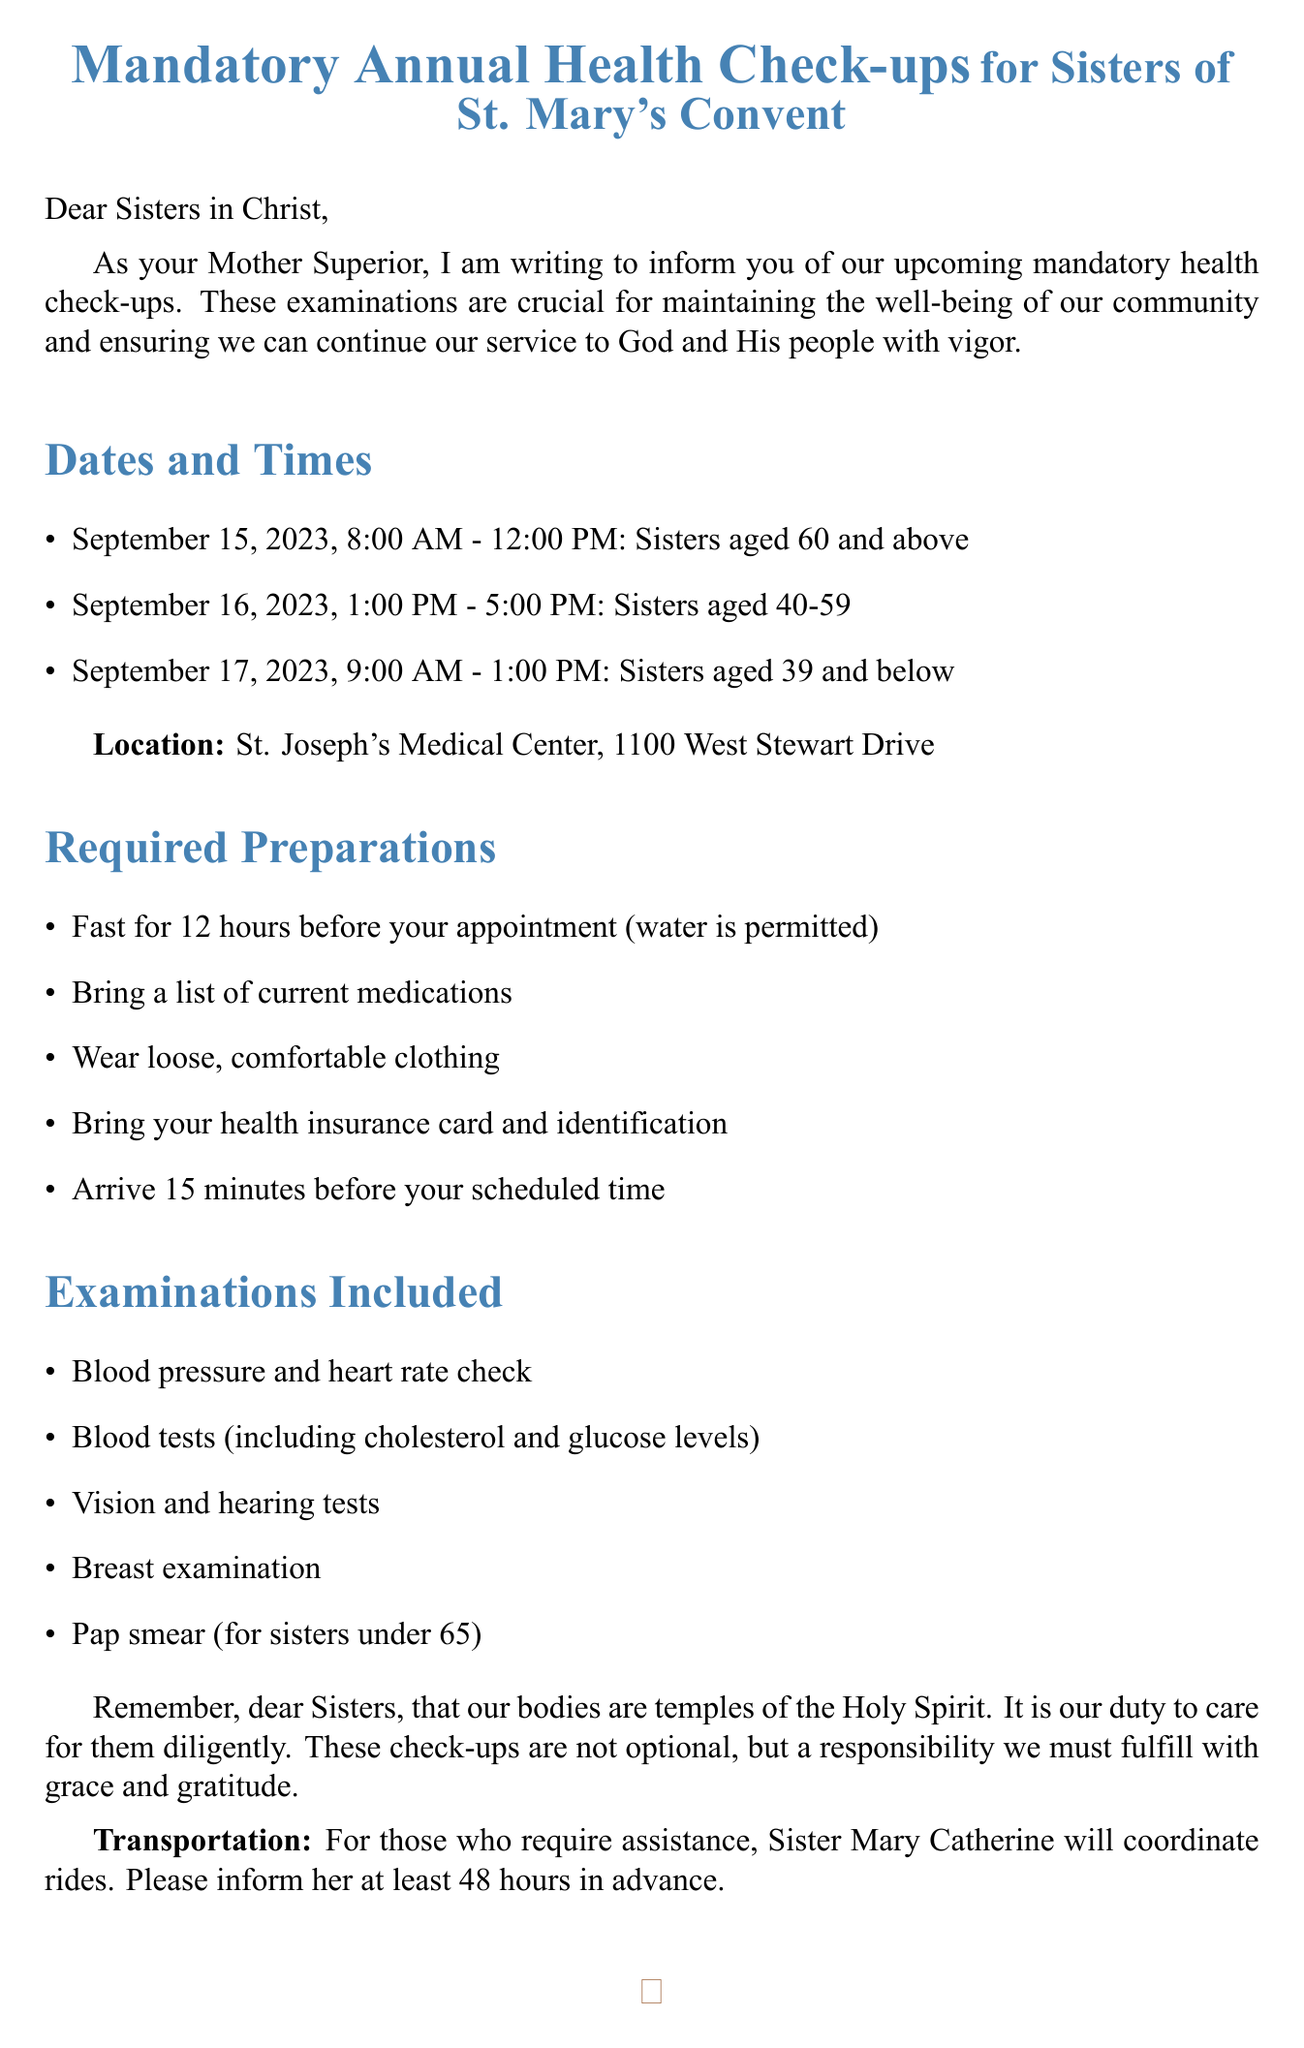What is the title of the memo? The title summarizes the purpose of the memo, which is about health check-ups for the sisters.
Answer: Mandatory Annual Health Check-ups for Sisters of St. Mary's Convent When is the health check-up for Sisters aged 40-59? This question pertains to the scheduling of health check-ups mentioned in the document.
Answer: September 16, 2023 What time should Sisters aged 39 and below arrive for their appointment? This reviews the preparation instructions related to timely arrival for health check-ups.
Answer: 15 minutes before their scheduled time Where will the health check-ups be held? This question seeks the location of the medical examinations specified in the memo.
Answer: St. Joseph's Medical Center, 1100 West Stewart Drive What is one of the required preparations for the health check-up? This examines the preparations required prior to the check-ups listed in the memo.
Answer: Fast for 12 hours before your appointment (water is permitted) How long after the check-ups will results be sent to the convent? The duration from the examinations to the receipt of results is a critical piece of information in the memo.
Answer: Two weeks Who will coordinate transportation for those in need? This question identifies the person responsible for arranging transportation as stated in the memo.
Answer: Sister Mary Catherine What is the religious context mentioned in the memo? This seeks to understand the principle guiding the health check-ups and caring for oneself as stated in the introduction.
Answer: Our bodies are temples of the Holy Spirit 